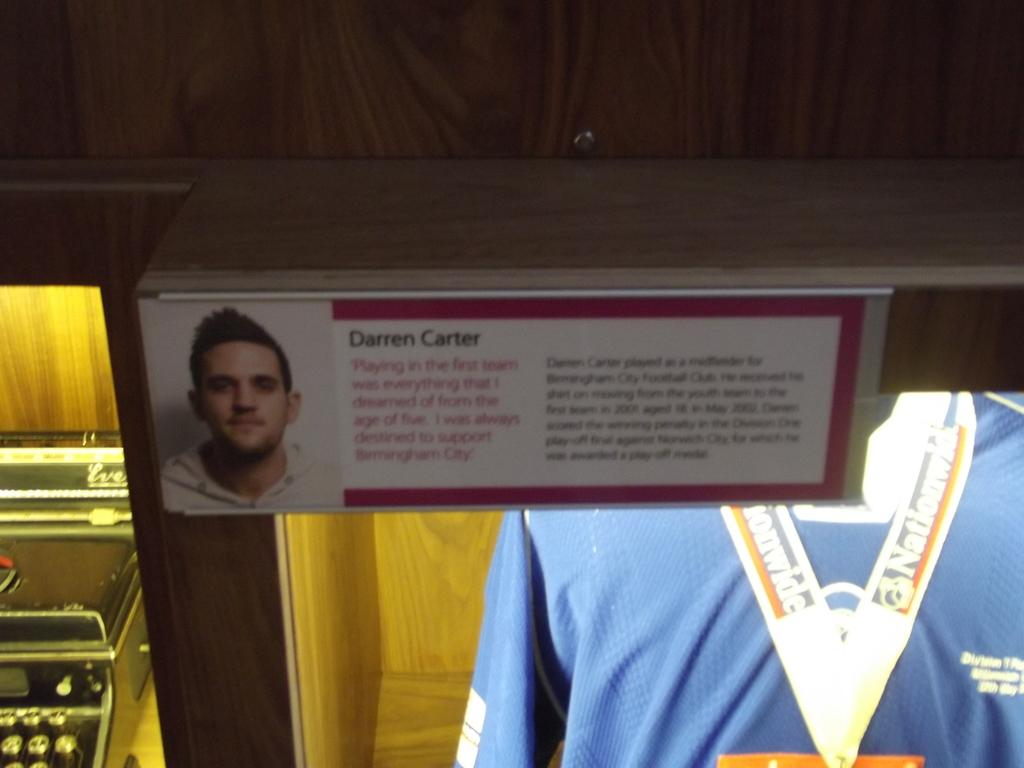<image>
Write a terse but informative summary of the picture. Sign showing a man's face and the name Darren Carter on it. 